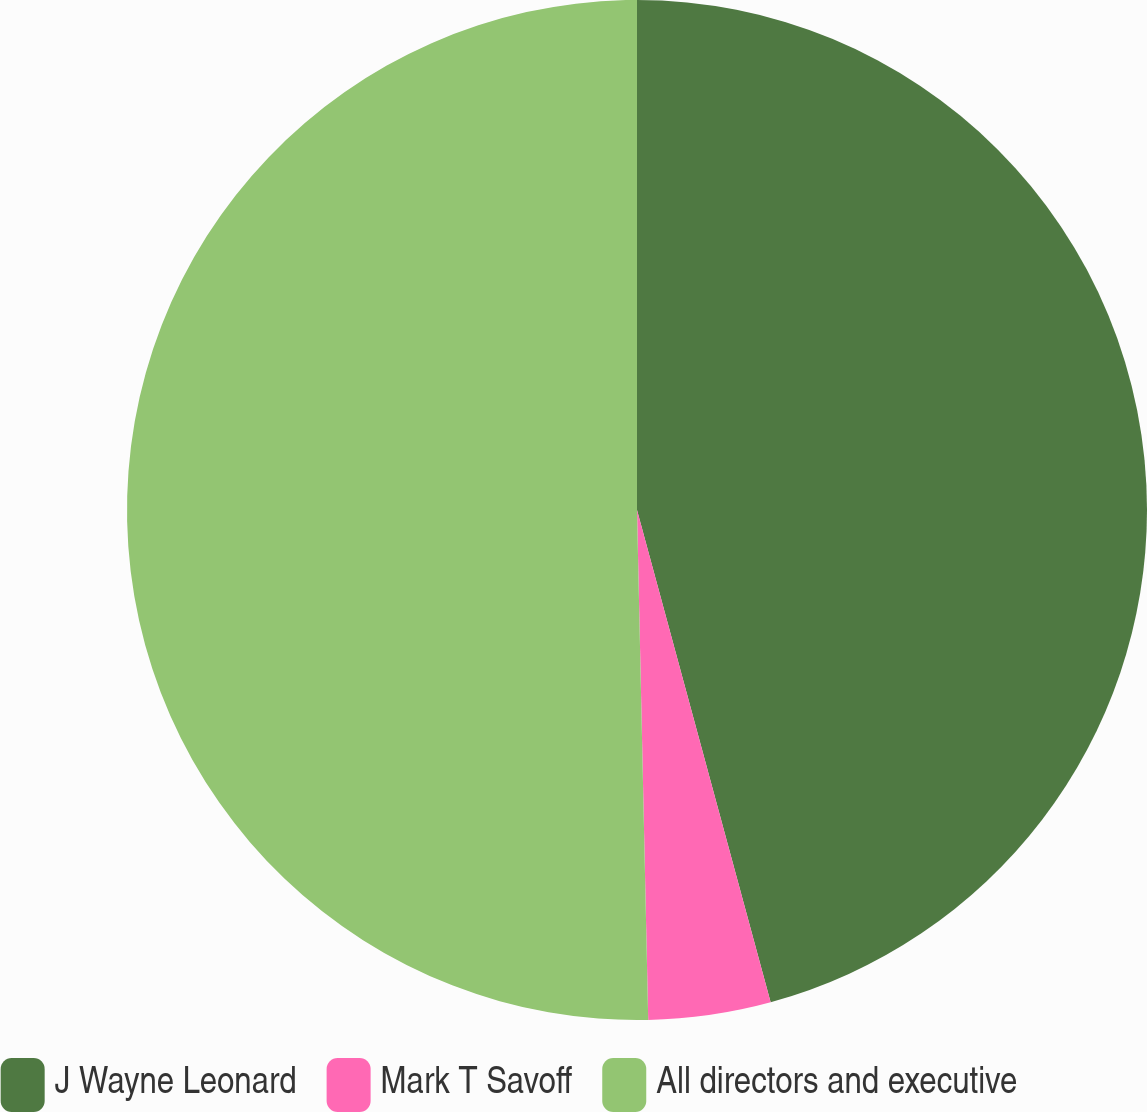<chart> <loc_0><loc_0><loc_500><loc_500><pie_chart><fcel>J Wayne Leonard<fcel>Mark T Savoff<fcel>All directors and executive<nl><fcel>45.78%<fcel>3.87%<fcel>50.35%<nl></chart> 